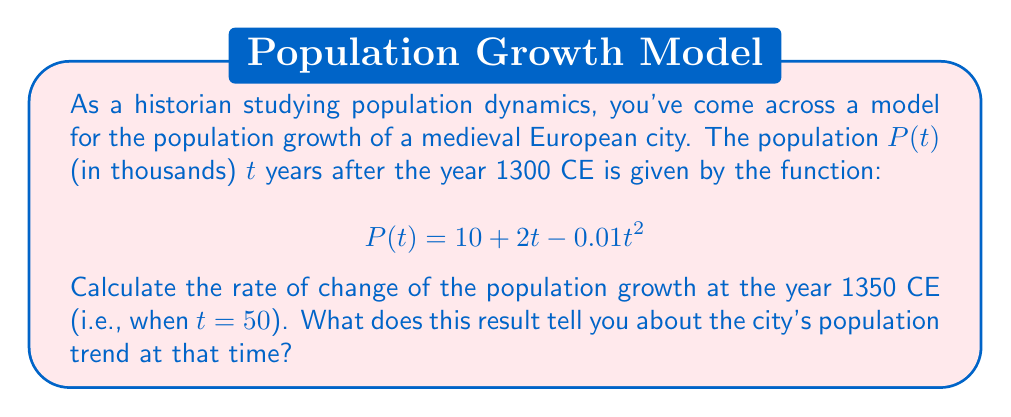Solve this math problem. To solve this problem, we need to follow these steps:

1) First, we need to find the derivative of the population function $P(t)$. This will give us the rate of change of the population with respect to time.

   $$\frac{d}{dt}P(t) = \frac{d}{dt}(10 + 2t - 0.01t^2)$$
   $$P'(t) = 2 - 0.02t$$

2) Now that we have the derivative, we can calculate the rate of change at any given time by plugging in the t-value.

3) We're asked to find the rate of change in 1350 CE, which is 50 years after 1300 CE. So we'll substitute $t = 50$ into our derivative function:

   $$P'(50) = 2 - 0.02(50)$$
   $$P'(50) = 2 - 1 = 1$$

4) Interpreting the result:
   The rate of change is 1 thousand people per year, or 1,000 people per year.
   
   Since this value is positive, it means the population was still growing in 1350 CE, but at a slower rate than initially. (We can see this because the derivative is decreasing as t increases.)

This aligns with historical knowledge: many European cities experienced rapid growth in the High Middle Ages, but this growth began to slow by the mid-14th century, partly due to factors like the Black Death which began in 1347.
Answer: The rate of change of the population in 1350 CE is 1 thousand people per year (or 1,000 people per year), indicating the population was still growing but at a decreasing rate. 